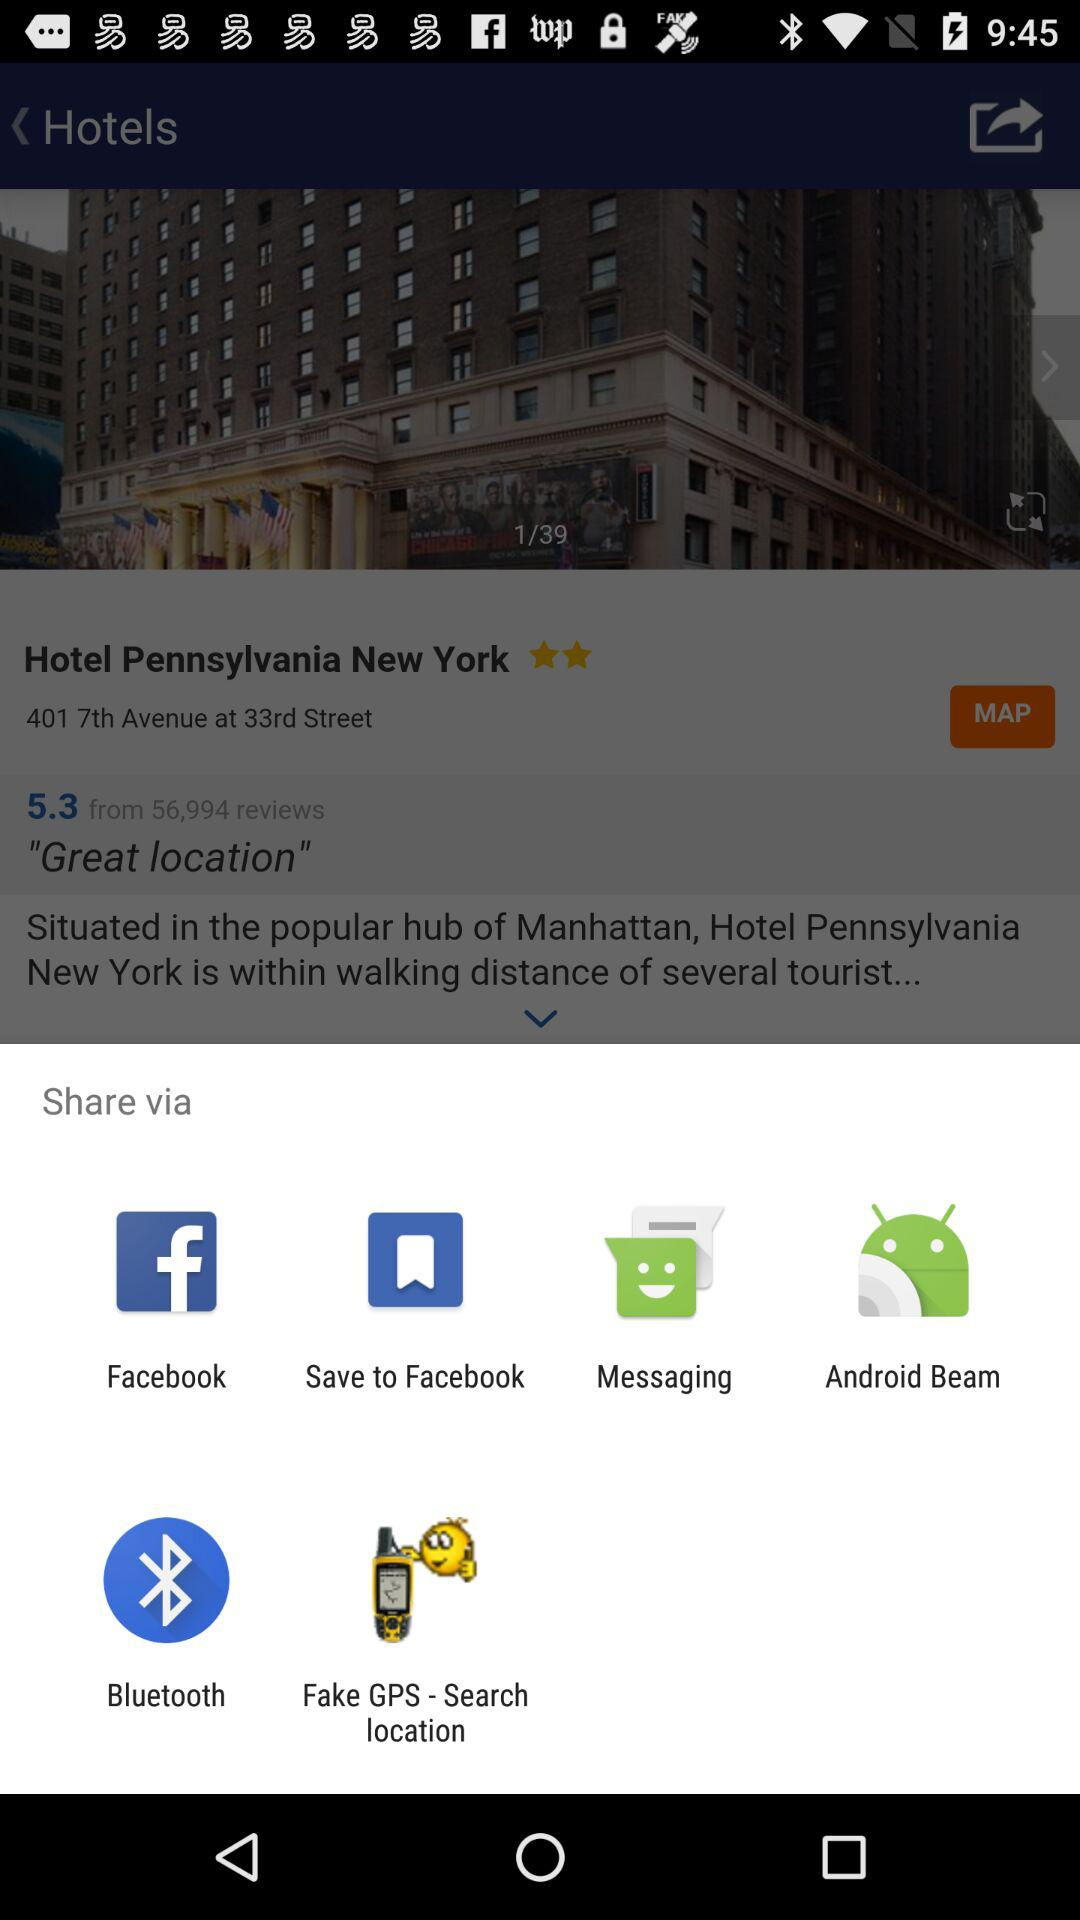Through which app can we share? You can share through "Facebook", "Save to Facebook", "Messaging", "Android Beam", "Bluetooth" and "Fake GPS - Search location". 